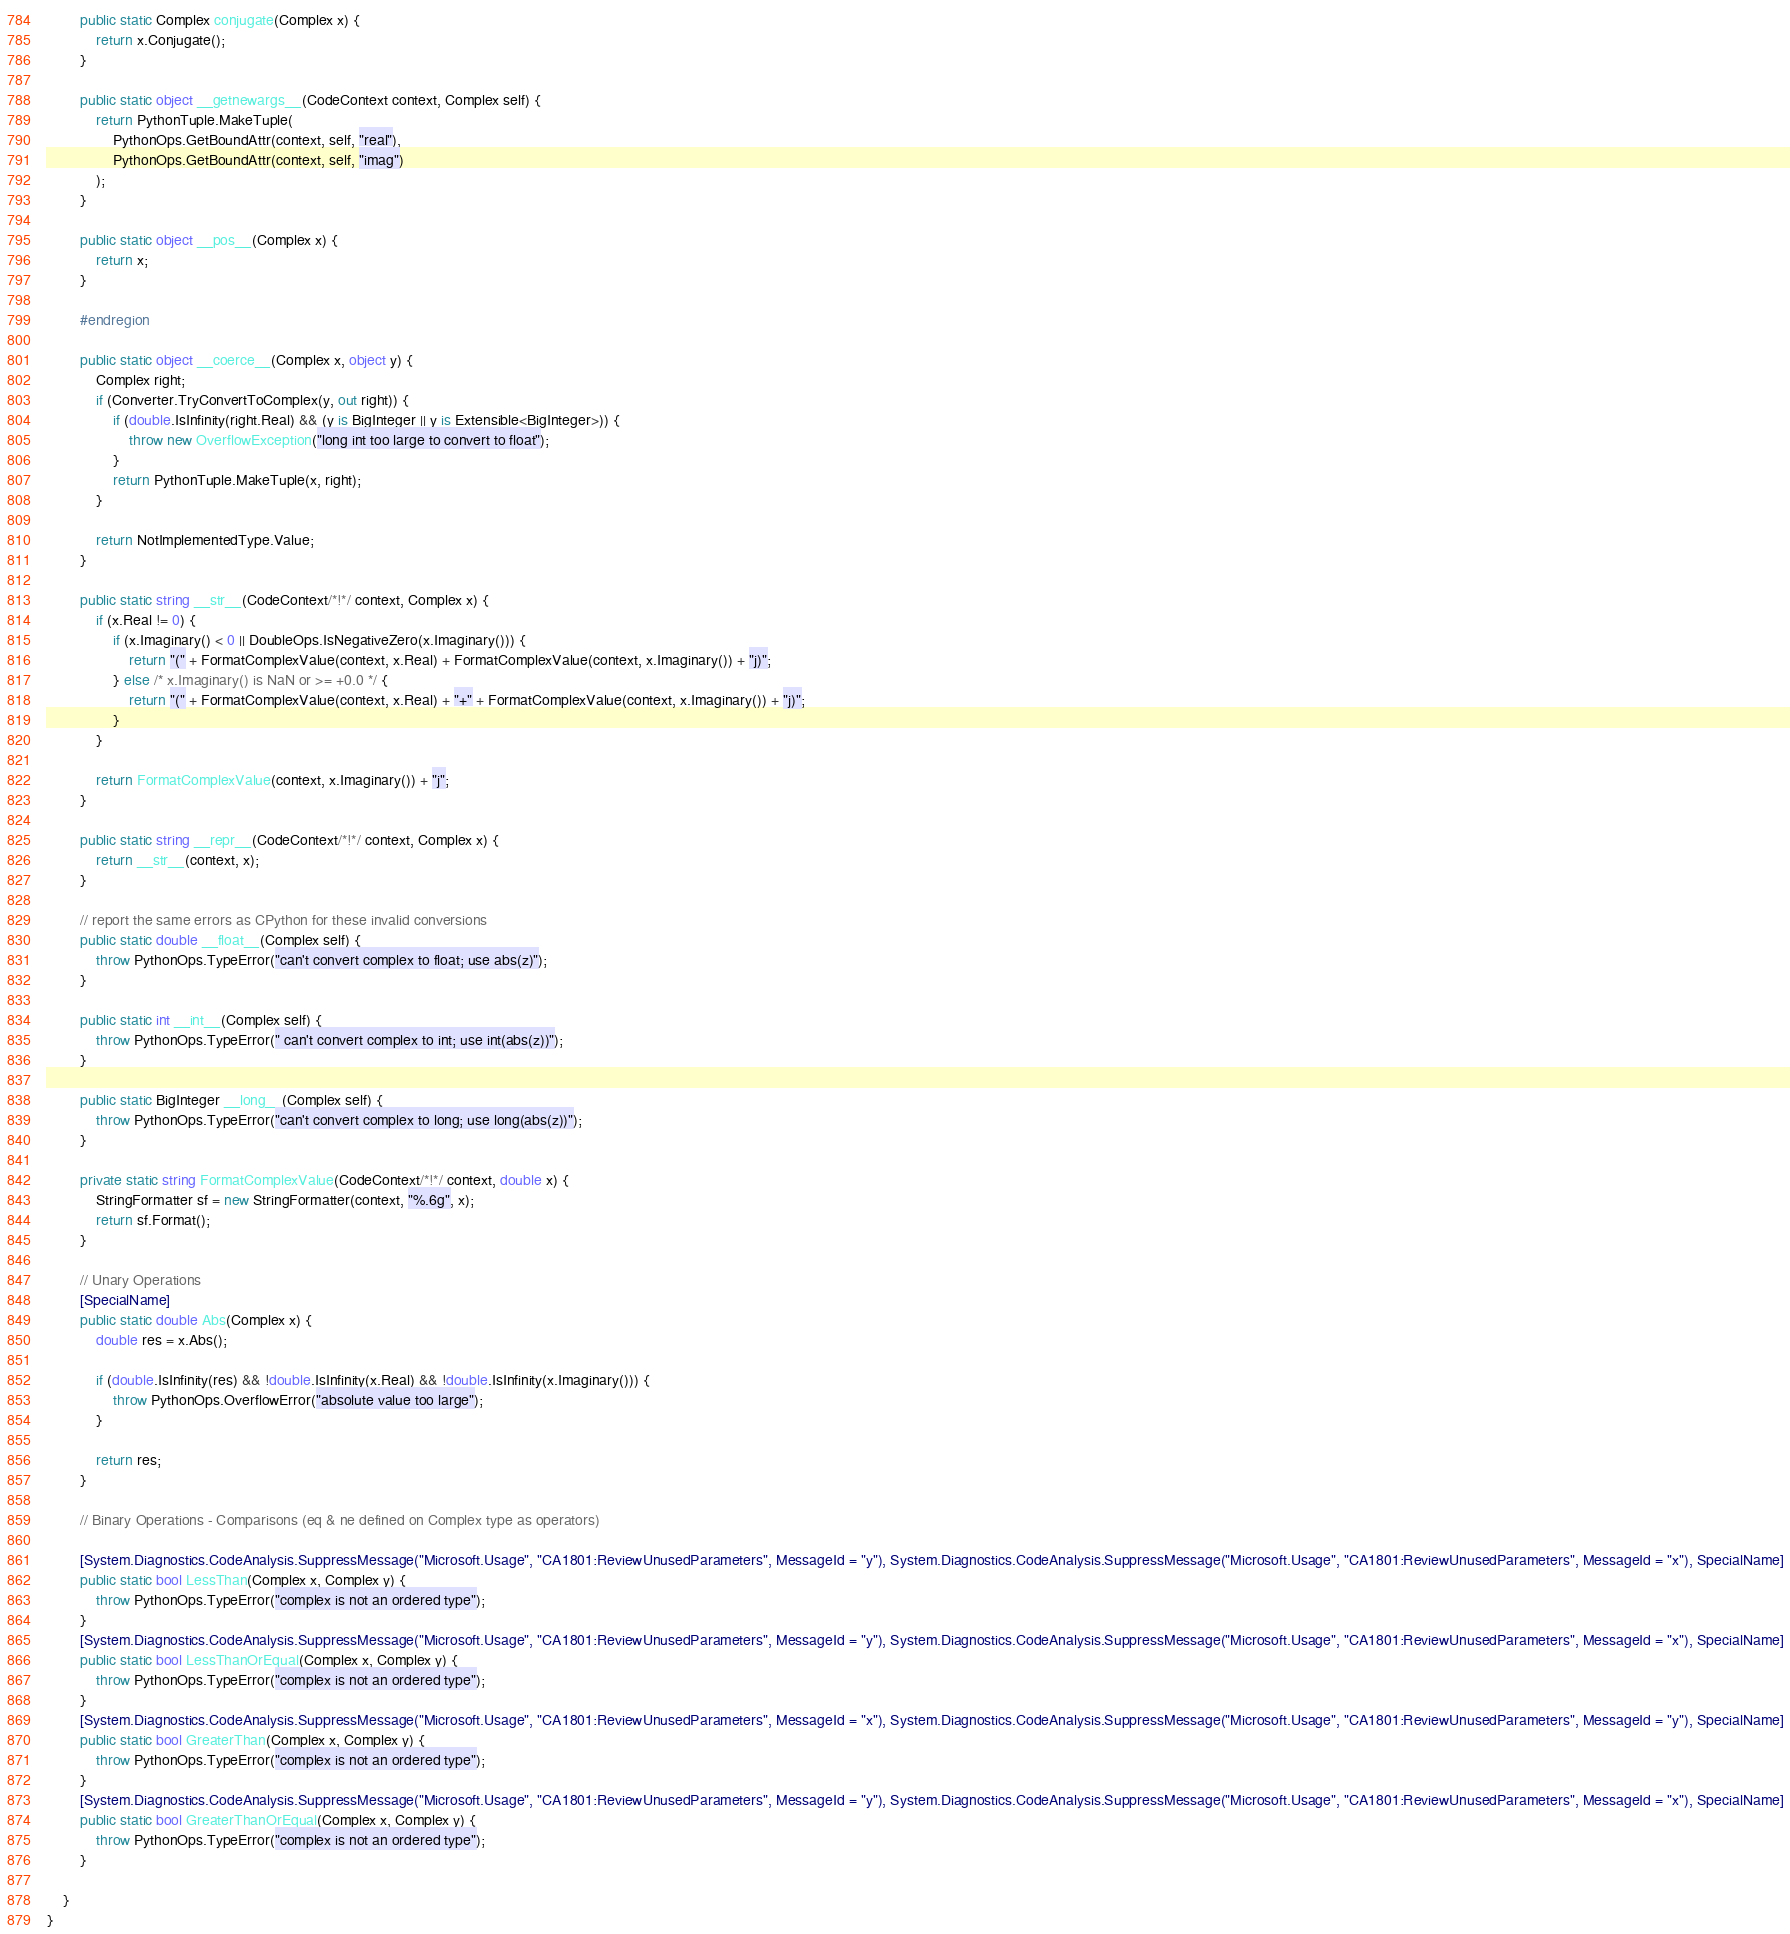<code> <loc_0><loc_0><loc_500><loc_500><_C#_>        public static Complex conjugate(Complex x) {
            return x.Conjugate();
        }

        public static object __getnewargs__(CodeContext context, Complex self) {
            return PythonTuple.MakeTuple(
                PythonOps.GetBoundAttr(context, self, "real"),
                PythonOps.GetBoundAttr(context, self, "imag")
            );
        }

        public static object __pos__(Complex x) {
            return x;
        }

        #endregion

        public static object __coerce__(Complex x, object y) {
            Complex right;
            if (Converter.TryConvertToComplex(y, out right)) {
                if (double.IsInfinity(right.Real) && (y is BigInteger || y is Extensible<BigInteger>)) {
                    throw new OverflowException("long int too large to convert to float");
                }
                return PythonTuple.MakeTuple(x, right);
            }

            return NotImplementedType.Value;
        }

        public static string __str__(CodeContext/*!*/ context, Complex x) {
            if (x.Real != 0) {
                if (x.Imaginary() < 0 || DoubleOps.IsNegativeZero(x.Imaginary())) {
                    return "(" + FormatComplexValue(context, x.Real) + FormatComplexValue(context, x.Imaginary()) + "j)";
                } else /* x.Imaginary() is NaN or >= +0.0 */ {
                    return "(" + FormatComplexValue(context, x.Real) + "+" + FormatComplexValue(context, x.Imaginary()) + "j)";
                }
            }

            return FormatComplexValue(context, x.Imaginary()) + "j";
        }

        public static string __repr__(CodeContext/*!*/ context, Complex x) {
            return __str__(context, x);
        }

        // report the same errors as CPython for these invalid conversions
        public static double __float__(Complex self) {
            throw PythonOps.TypeError("can't convert complex to float; use abs(z)");
        }

        public static int __int__(Complex self) {
            throw PythonOps.TypeError(" can't convert complex to int; use int(abs(z))");
        }

        public static BigInteger __long__(Complex self) {
            throw PythonOps.TypeError("can't convert complex to long; use long(abs(z))");
        }

        private static string FormatComplexValue(CodeContext/*!*/ context, double x) {
            StringFormatter sf = new StringFormatter(context, "%.6g", x);
            return sf.Format();
        }
        
        // Unary Operations
        [SpecialName]
        public static double Abs(Complex x) {
            double res = x.Abs();

            if (double.IsInfinity(res) && !double.IsInfinity(x.Real) && !double.IsInfinity(x.Imaginary())) {
                throw PythonOps.OverflowError("absolute value too large");
            }

            return res;
        }

        // Binary Operations - Comparisons (eq & ne defined on Complex type as operators)

        [System.Diagnostics.CodeAnalysis.SuppressMessage("Microsoft.Usage", "CA1801:ReviewUnusedParameters", MessageId = "y"), System.Diagnostics.CodeAnalysis.SuppressMessage("Microsoft.Usage", "CA1801:ReviewUnusedParameters", MessageId = "x"), SpecialName]
        public static bool LessThan(Complex x, Complex y) {
            throw PythonOps.TypeError("complex is not an ordered type");
        }
        [System.Diagnostics.CodeAnalysis.SuppressMessage("Microsoft.Usage", "CA1801:ReviewUnusedParameters", MessageId = "y"), System.Diagnostics.CodeAnalysis.SuppressMessage("Microsoft.Usage", "CA1801:ReviewUnusedParameters", MessageId = "x"), SpecialName]
        public static bool LessThanOrEqual(Complex x, Complex y) {
            throw PythonOps.TypeError("complex is not an ordered type");
        }
        [System.Diagnostics.CodeAnalysis.SuppressMessage("Microsoft.Usage", "CA1801:ReviewUnusedParameters", MessageId = "x"), System.Diagnostics.CodeAnalysis.SuppressMessage("Microsoft.Usage", "CA1801:ReviewUnusedParameters", MessageId = "y"), SpecialName]
        public static bool GreaterThan(Complex x, Complex y) {
            throw PythonOps.TypeError("complex is not an ordered type");
        }
        [System.Diagnostics.CodeAnalysis.SuppressMessage("Microsoft.Usage", "CA1801:ReviewUnusedParameters", MessageId = "y"), System.Diagnostics.CodeAnalysis.SuppressMessage("Microsoft.Usage", "CA1801:ReviewUnusedParameters", MessageId = "x"), SpecialName]
        public static bool GreaterThanOrEqual(Complex x, Complex y) {
            throw PythonOps.TypeError("complex is not an ordered type");
        }

    }
}
</code> 